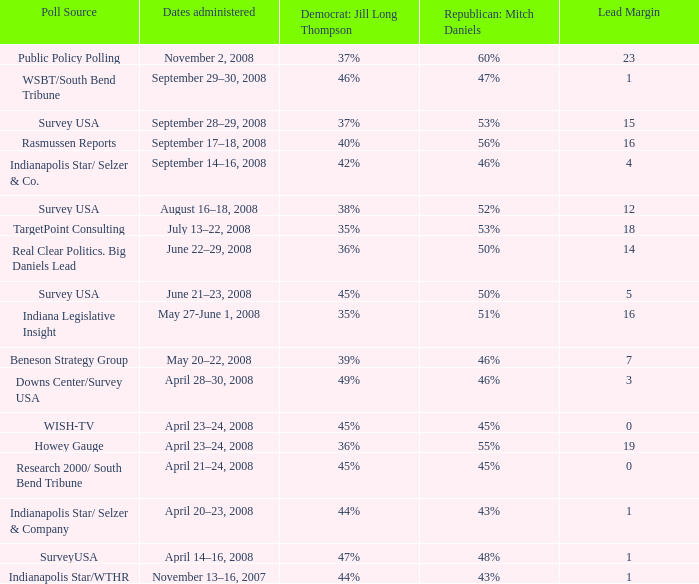What is the lowest Lead Margin when Republican: Mitch Daniels was polling at 48%? 1.0. 